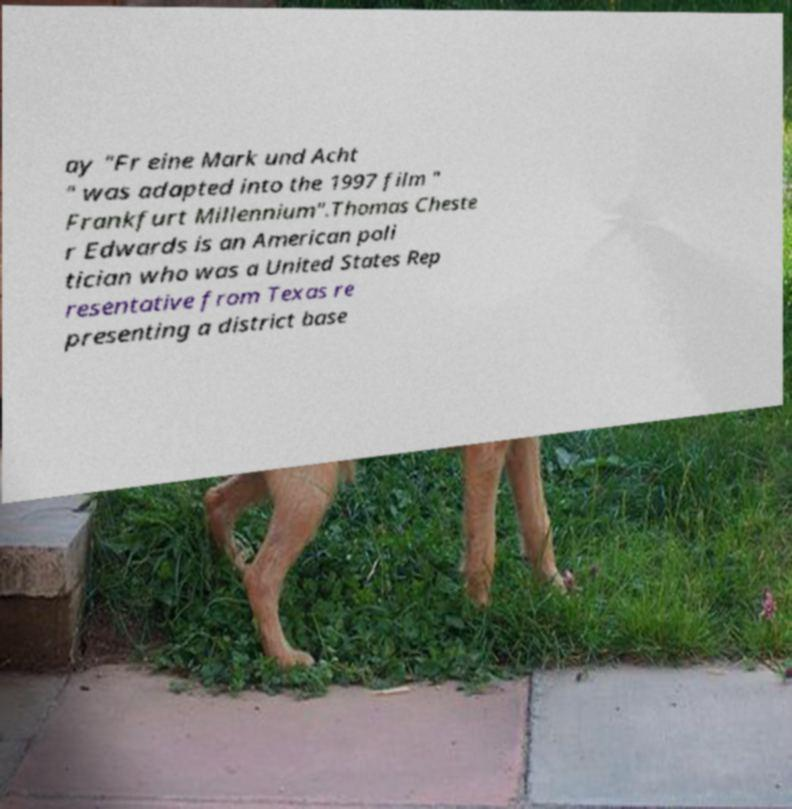Can you accurately transcribe the text from the provided image for me? ay "Fr eine Mark und Acht " was adapted into the 1997 film " Frankfurt Millennium".Thomas Cheste r Edwards is an American poli tician who was a United States Rep resentative from Texas re presenting a district base 